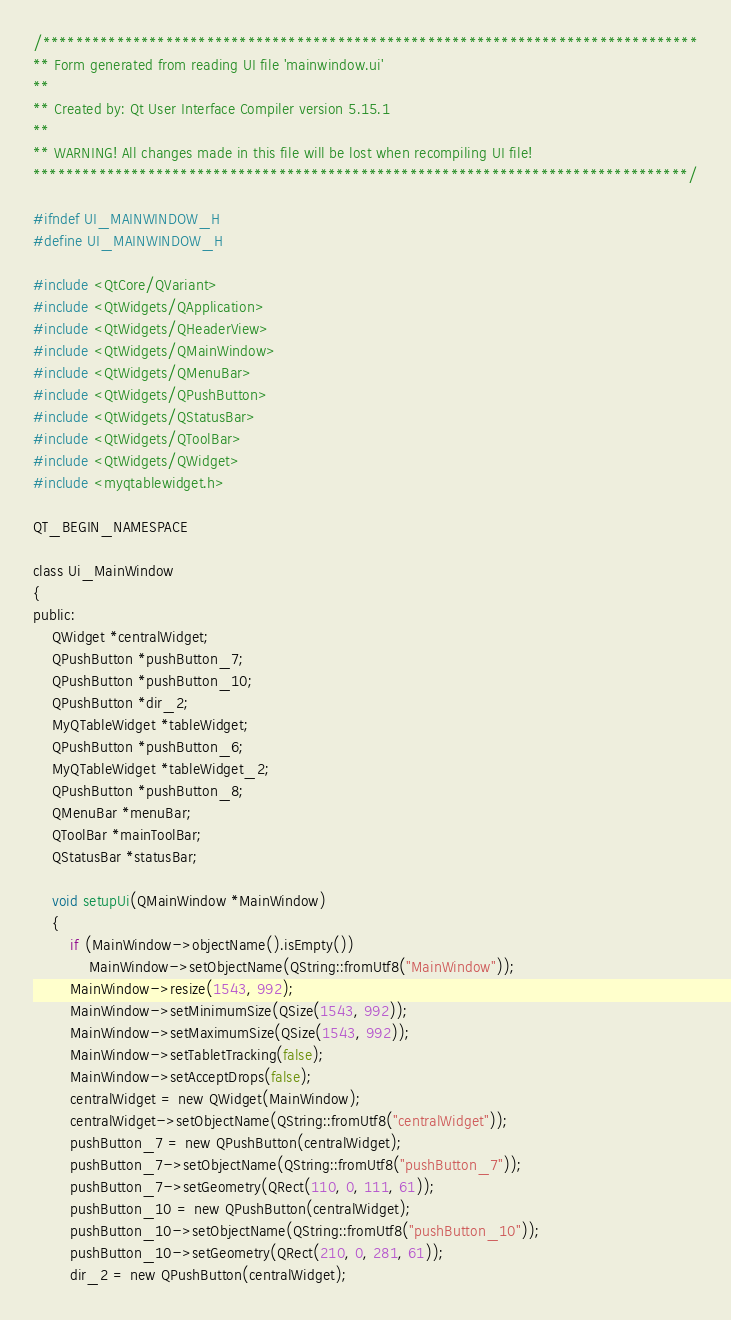<code> <loc_0><loc_0><loc_500><loc_500><_C_>/********************************************************************************
** Form generated from reading UI file 'mainwindow.ui'
**
** Created by: Qt User Interface Compiler version 5.15.1
**
** WARNING! All changes made in this file will be lost when recompiling UI file!
********************************************************************************/

#ifndef UI_MAINWINDOW_H
#define UI_MAINWINDOW_H

#include <QtCore/QVariant>
#include <QtWidgets/QApplication>
#include <QtWidgets/QHeaderView>
#include <QtWidgets/QMainWindow>
#include <QtWidgets/QMenuBar>
#include <QtWidgets/QPushButton>
#include <QtWidgets/QStatusBar>
#include <QtWidgets/QToolBar>
#include <QtWidgets/QWidget>
#include <myqtablewidget.h>

QT_BEGIN_NAMESPACE

class Ui_MainWindow
{
public:
    QWidget *centralWidget;
    QPushButton *pushButton_7;
    QPushButton *pushButton_10;
    QPushButton *dir_2;
    MyQTableWidget *tableWidget;
    QPushButton *pushButton_6;
    MyQTableWidget *tableWidget_2;
    QPushButton *pushButton_8;
    QMenuBar *menuBar;
    QToolBar *mainToolBar;
    QStatusBar *statusBar;

    void setupUi(QMainWindow *MainWindow)
    {
        if (MainWindow->objectName().isEmpty())
            MainWindow->setObjectName(QString::fromUtf8("MainWindow"));
        MainWindow->resize(1543, 992);
        MainWindow->setMinimumSize(QSize(1543, 992));
        MainWindow->setMaximumSize(QSize(1543, 992));
        MainWindow->setTabletTracking(false);
        MainWindow->setAcceptDrops(false);
        centralWidget = new QWidget(MainWindow);
        centralWidget->setObjectName(QString::fromUtf8("centralWidget"));
        pushButton_7 = new QPushButton(centralWidget);
        pushButton_7->setObjectName(QString::fromUtf8("pushButton_7"));
        pushButton_7->setGeometry(QRect(110, 0, 111, 61));
        pushButton_10 = new QPushButton(centralWidget);
        pushButton_10->setObjectName(QString::fromUtf8("pushButton_10"));
        pushButton_10->setGeometry(QRect(210, 0, 281, 61));
        dir_2 = new QPushButton(centralWidget);</code> 